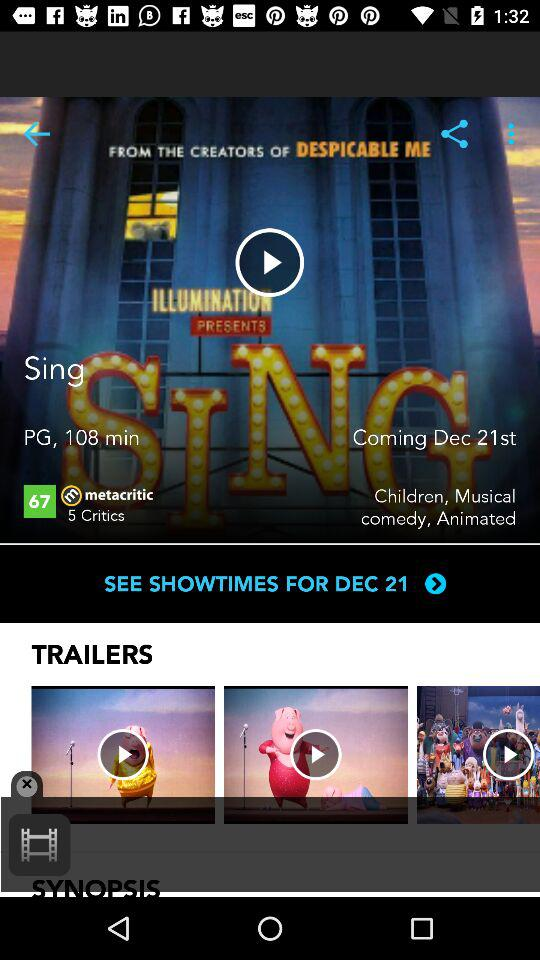How many trailers are there for this movie?
Answer the question using a single word or phrase. 3 